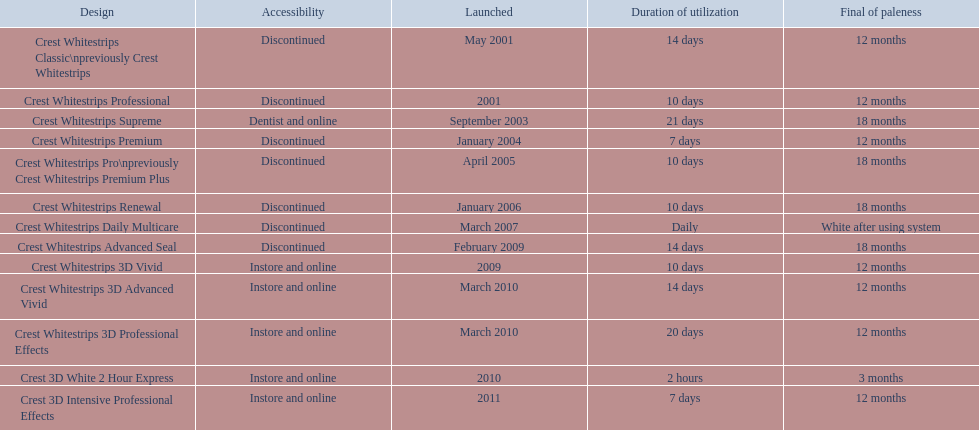Crest 3d intensive professional effects and crest whitestrips 3d professional effects both have a lasting whiteness of how many months? 12 months. Parse the table in full. {'header': ['Design', 'Accessibility', 'Launched', 'Duration of utilization', 'Final of paleness'], 'rows': [['Crest Whitestrips Classic\\npreviously Crest Whitestrips', 'Discontinued', 'May 2001', '14 days', '12 months'], ['Crest Whitestrips Professional', 'Discontinued', '2001', '10 days', '12 months'], ['Crest Whitestrips Supreme', 'Dentist and online', 'September 2003', '21 days', '18 months'], ['Crest Whitestrips Premium', 'Discontinued', 'January 2004', '7 days', '12 months'], ['Crest Whitestrips Pro\\npreviously Crest Whitestrips Premium Plus', 'Discontinued', 'April 2005', '10 days', '18 months'], ['Crest Whitestrips Renewal', 'Discontinued', 'January 2006', '10 days', '18 months'], ['Crest Whitestrips Daily Multicare', 'Discontinued', 'March 2007', 'Daily', 'White after using system'], ['Crest Whitestrips Advanced Seal', 'Discontinued', 'February 2009', '14 days', '18 months'], ['Crest Whitestrips 3D Vivid', 'Instore and online', '2009', '10 days', '12 months'], ['Crest Whitestrips 3D Advanced Vivid', 'Instore and online', 'March 2010', '14 days', '12 months'], ['Crest Whitestrips 3D Professional Effects', 'Instore and online', 'March 2010', '20 days', '12 months'], ['Crest 3D White 2 Hour Express', 'Instore and online', '2010', '2 hours', '3 months'], ['Crest 3D Intensive Professional Effects', 'Instore and online', '2011', '7 days', '12 months']]} 